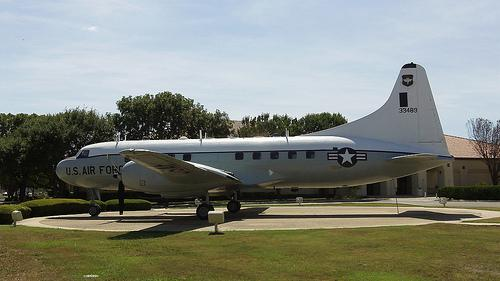Question: what is this?
Choices:
A. A bowl.
B. An aeroplane.
C. A fish.
D. Jumper cables.
Answer with the letter. Answer: B Question: what does it represent?
Choices:
A. US AIR FORCE.
B. A function.
C. An equation.
D. A soldier.
Answer with the letter. Answer: A Question: how is the weather?
Choices:
A. It is clear.
B. It is sunny.
C. It is foggy.
D. It is beautiful.
Answer with the letter. Answer: B Question: where is it?
Choices:
A. In the water.
B. In the tree.
C. In the box.
D. Outside a building.
Answer with the letter. Answer: D 